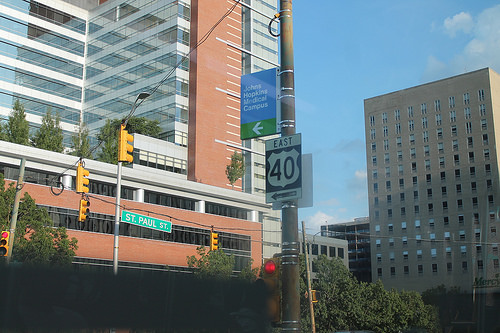<image>
Is there a sign on the building? No. The sign is not positioned on the building. They may be near each other, but the sign is not supported by or resting on top of the building. 